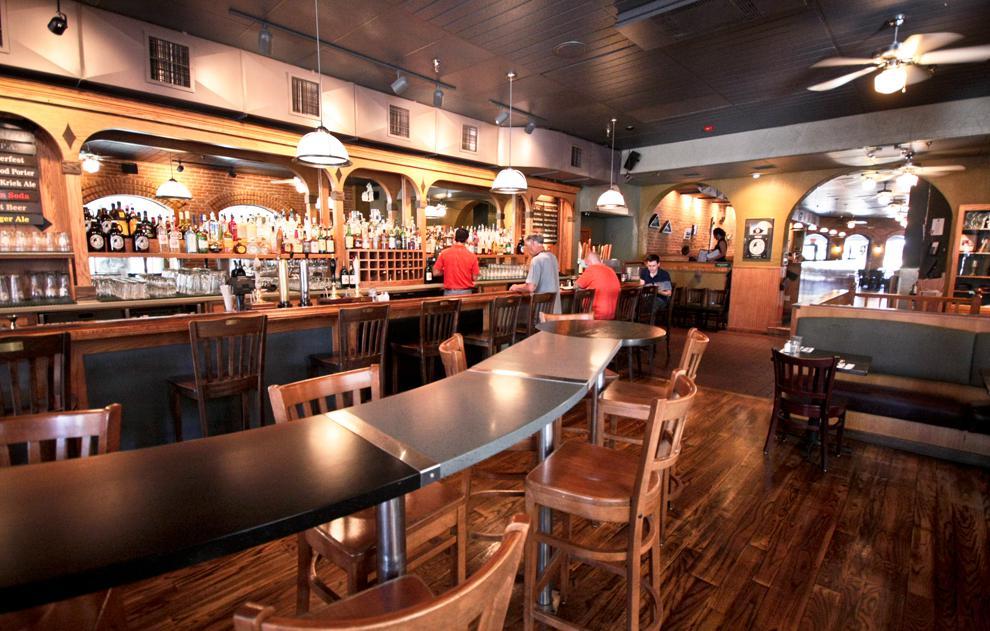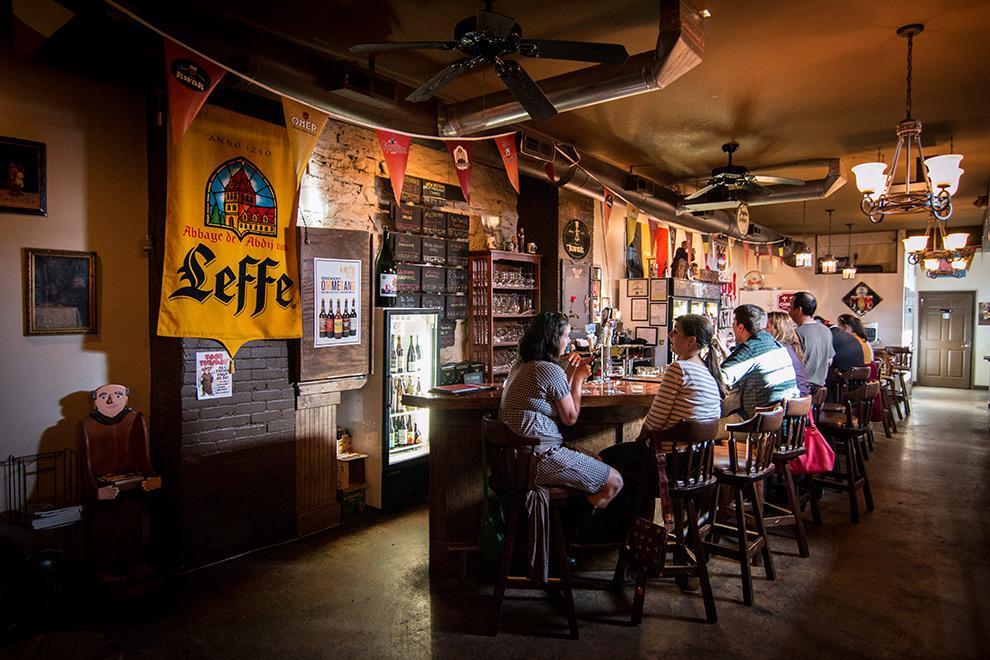The first image is the image on the left, the second image is the image on the right. Evaluate the accuracy of this statement regarding the images: "There are televisions in exactly one of the imagtes.". Is it true? Answer yes or no. No. 